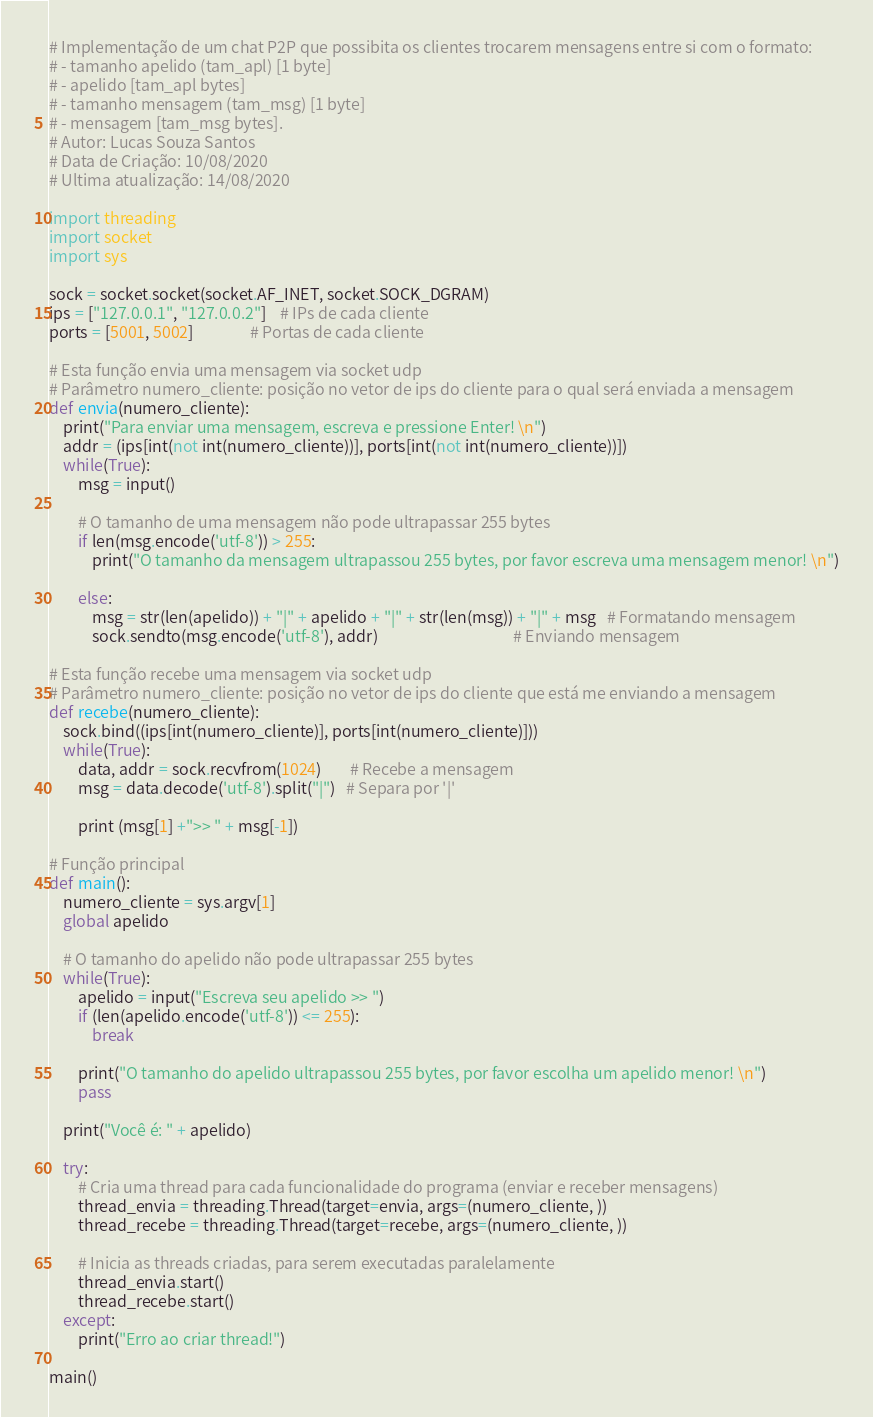<code> <loc_0><loc_0><loc_500><loc_500><_Python_># Implementação de um chat P2P que possibita os clientes trocarem mensagens entre si com o formato:
# - tamanho apelido (tam_apl) [1 byte]
# - apelido [tam_apl bytes]
# - tamanho mensagem (tam_msg) [1 byte]
# - mensagem [tam_msg bytes].
# Autor: Lucas Souza Santos 
# Data de Criação: 10/08/2020
# Ultima atualização: 14/08/2020

import threading
import socket
import sys

sock = socket.socket(socket.AF_INET, socket.SOCK_DGRAM)
ips = ["127.0.0.1", "127.0.0.2"]    # IPs de cada cliente
ports = [5001, 5002]                # Portas de cada cliente

# Esta função envia uma mensagem via socket udp
# Parâmetro numero_cliente: posição no vetor de ips do cliente para o qual será enviada a mensagem
def envia(numero_cliente):
    print("Para enviar uma mensagem, escreva e pressione Enter! \n")
    addr = (ips[int(not int(numero_cliente))], ports[int(not int(numero_cliente))])
    while(True):
        msg = input()

        # O tamanho de uma mensagem não pode ultrapassar 255 bytes
        if len(msg.encode('utf-8')) > 255:
            print("O tamanho da mensagem ultrapassou 255 bytes, por favor escreva uma mensagem menor! \n")

        else:
            msg = str(len(apelido)) + "|" + apelido + "|" + str(len(msg)) + "|" + msg   # Formatando mensagem
            sock.sendto(msg.encode('utf-8'), addr)                                      # Enviando mensagem

# Esta função recebe uma mensagem via socket udp
# Parâmetro numero_cliente: posição no vetor de ips do cliente que está me enviando a mensagem
def recebe(numero_cliente):
    sock.bind((ips[int(numero_cliente)], ports[int(numero_cliente)]))
    while(True):
        data, addr = sock.recvfrom(1024)        # Recebe a mensagem
        msg = data.decode('utf-8').split("|")   # Separa por '|'

        print (msg[1] +">> " + msg[-1])

# Função principal
def main():
    numero_cliente = sys.argv[1]
    global apelido

    # O tamanho do apelido não pode ultrapassar 255 bytes
    while(True):
        apelido = input("Escreva seu apelido >> ")
        if (len(apelido.encode('utf-8')) <= 255):
            break

        print("O tamanho do apelido ultrapassou 255 bytes, por favor escolha um apelido menor! \n")
        pass

    print("Você é: " + apelido)

    try:
        # Cria uma thread para cada funcionalidade do programa (enviar e receber mensagens)
        thread_envia = threading.Thread(target=envia, args=(numero_cliente, ))
        thread_recebe = threading.Thread(target=recebe, args=(numero_cliente, ))

        # Inicia as threads criadas, para serem executadas paralelamente
        thread_envia.start()
        thread_recebe.start()
    except:
        print("Erro ao criar thread!")

main()</code> 